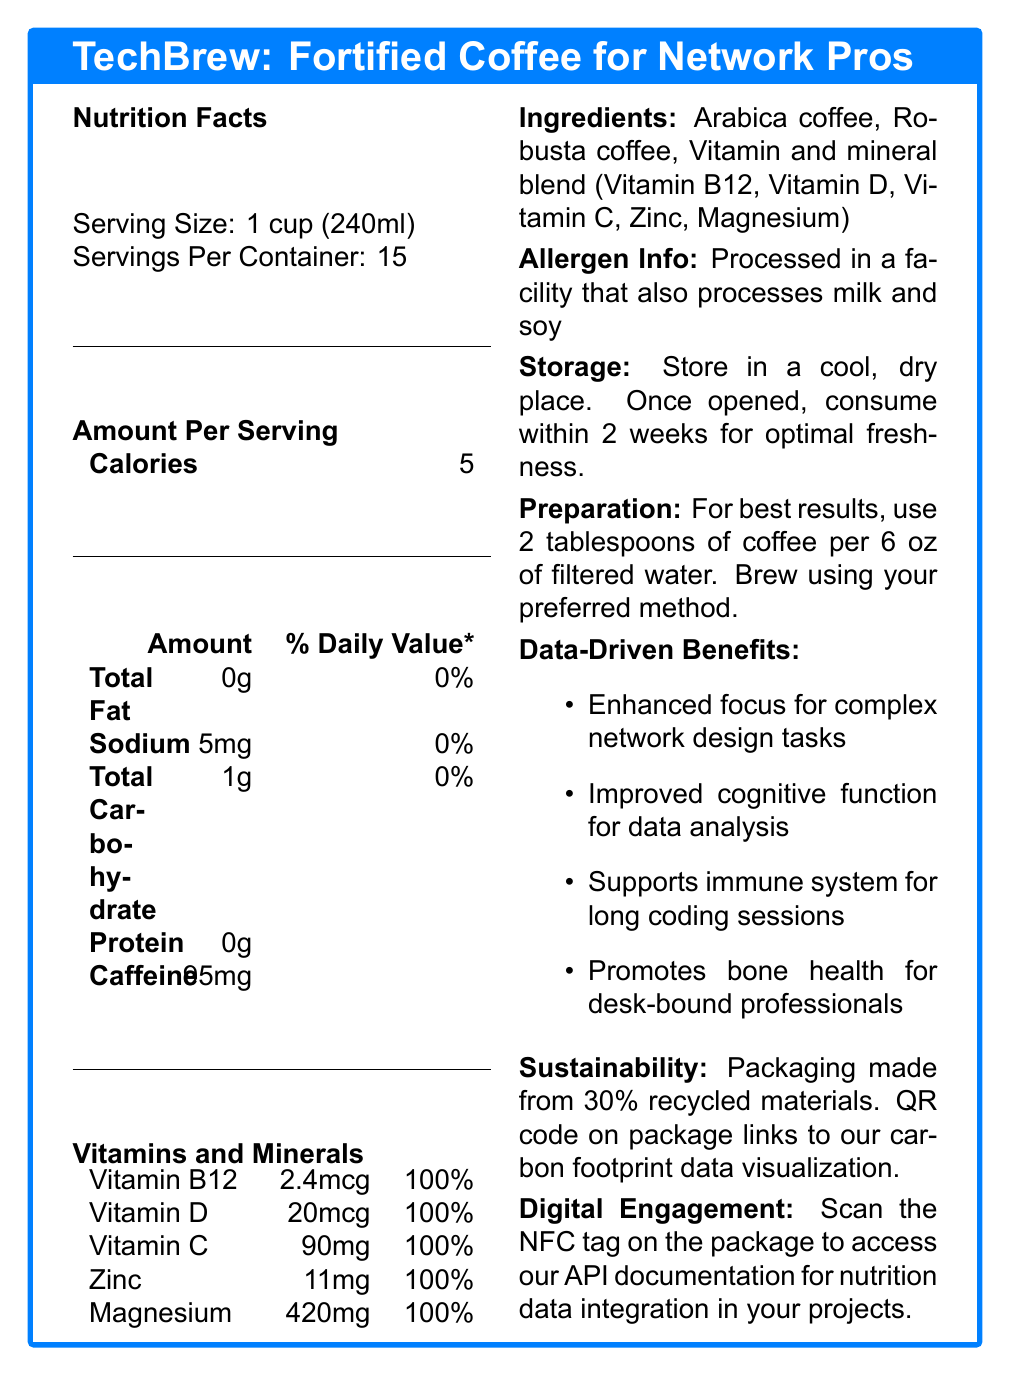what is the serving size of TechBrew? The serving size is explicitly mentioned as "1 cup (240ml)" under the Nutrition Facts section.
Answer: 1 cup (240ml) how many servings are there per container? It is stated directly under the Nutrition Facts section that there are 15 servings per container.
Answer: 15 how many calories are in a single serving? The document lists 5 calories per serving in the "Amount Per Serving" section.
Answer: 5 how much caffeine is in each serving? The amount of caffeine per serving is given as 95mg in the "Amount Per Serving" section.
Answer: 95mg which vitamins and minerals are present in TechBrew? Under the "Vitamins and Minerals" section, it lists the presence of Vitamin B12, Vitamin D, Vitamin C, Zinc, and Magnesium.
Answer: Vitamin B12, Vitamin D, Vitamin C, Zinc, Magnesium What is the amount of magnesium per serving? The amount of magnesium per serving is detailed as 420mg in the "Vitamins and Minerals" section.
Answer: 420mg which ingredient is not part of TechBrew? A. Robusta coffee B. Milk C. Vitamin B12 D. Arabica coffee The listed ingredients are Arabica coffee, Robusta coffee, and a vitamin and mineral blend (Vitamin B12, Vitamin D, Vitamin C, Zinc, Magnesium) and do not include milk.
Answer: B. Milk how should TechBrew be stored? The storage instructions are clearly stated in the document.
Answer: Store in a cool, dry place. Once opened, consume within 2 weeks for optimal freshness. Which percentage of recycled materials is used in TechBrew's packaging? A. 10% B. 20% C. 30% D. 40% The document states that the packaging is made from 30% recycled materials under the "Sustainability" section.
Answer: C. 30% is TechBrew suitable for someone with a soy allergy? The document mentions that TechBrew is "Processed in a facility that also processes milk and soy," suggesting potential cross-contamination.
Answer: No Can we determine the price of TechBrew from the document? The document does not provide any information regarding the price of TechBrew.
Answer: No, not enough information summarize the main idea of the TechBrew nutrition facts label. This summary encapsulates the main details provided in the document regarding TechBrew's nutritional benefits, ingredients, and additional features.
Answer: TechBrew is a vitamin-fortified coffee designed for network professionals, offering enhanced focus, cognitive function, and immune support. Each serving contains essential vitamins and minerals, has minimal calories, and is high in caffeine. It is packaged sustainably and provides digital engagement options through NFC tags. 